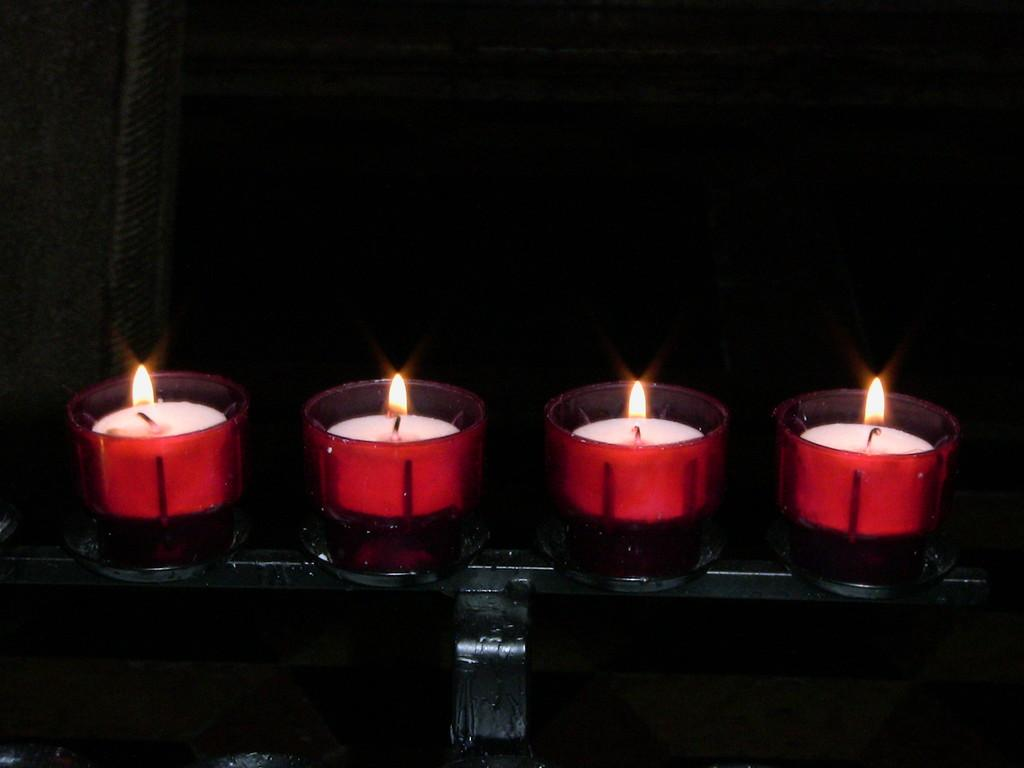What objects are present in the image? There are candles in the image. How are the candles arranged or contained? The candles are in glasses. Where are the glasses with candles located? The glasses with candles are on a stand. What type of feather can be seen causing anger in the image? There is no feather or indication of anger present in the image; it features candles in glasses on a stand. 